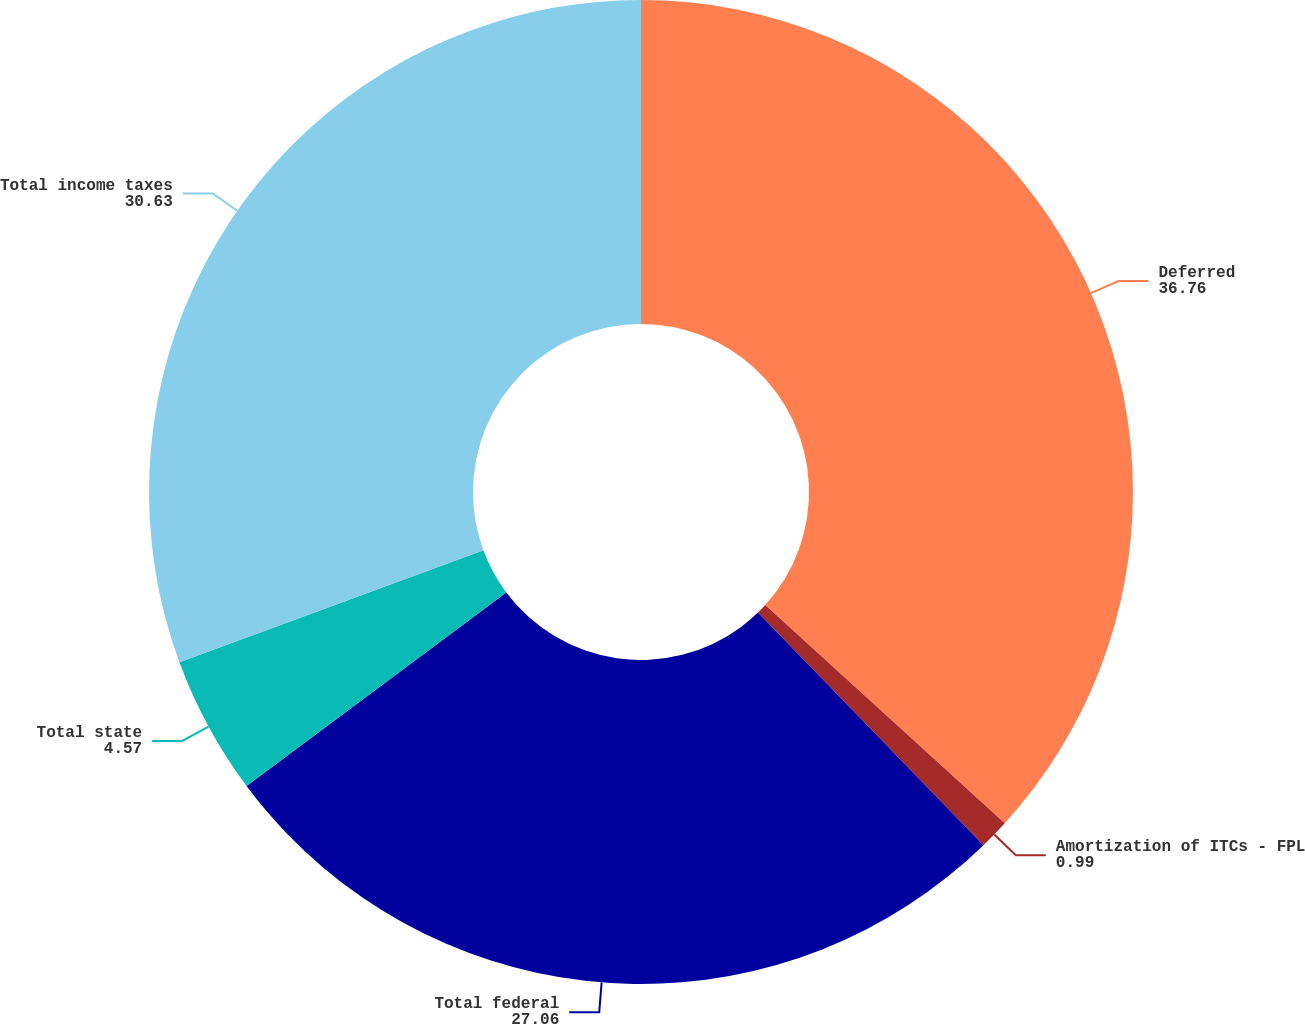Convert chart to OTSL. <chart><loc_0><loc_0><loc_500><loc_500><pie_chart><fcel>Deferred<fcel>Amortization of ITCs - FPL<fcel>Total federal<fcel>Total state<fcel>Total income taxes<nl><fcel>36.76%<fcel>0.99%<fcel>27.06%<fcel>4.57%<fcel>30.63%<nl></chart> 